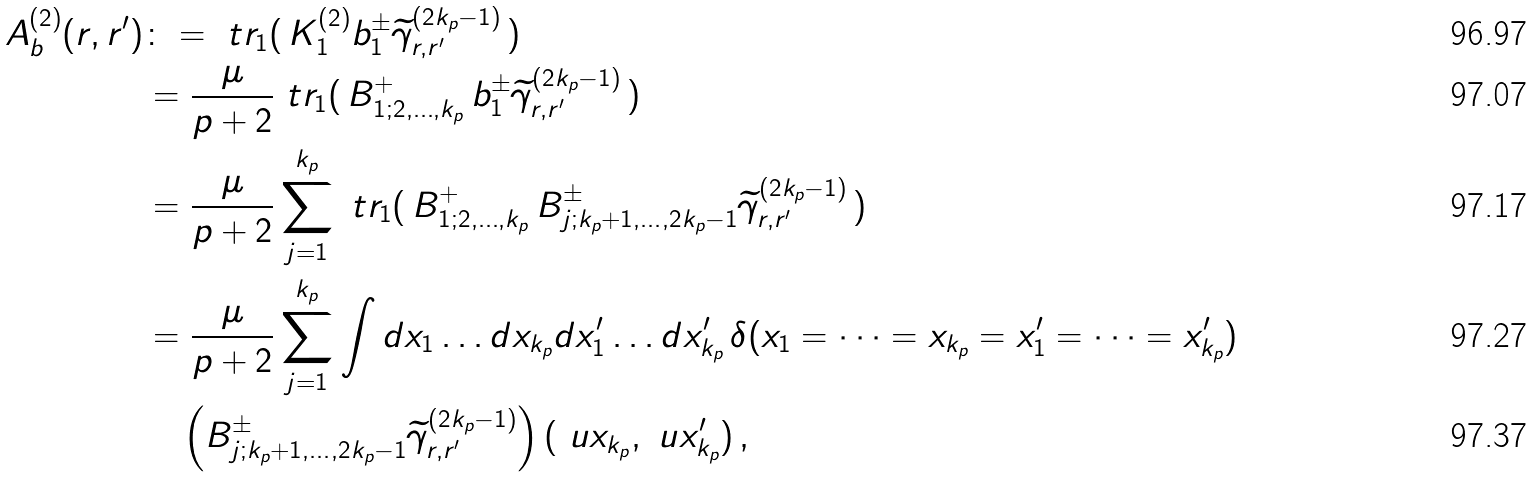<formula> <loc_0><loc_0><loc_500><loc_500>A _ { b } ^ { ( 2 ) } ( r , r ^ { \prime } ) & \colon = \ t r _ { 1 } ( \, K _ { 1 } ^ { ( 2 ) } b _ { 1 } ^ { \pm } \widetilde { \gamma } ^ { ( 2 k _ { p } - 1 ) } _ { r , r ^ { \prime } } \, ) \\ & = \frac { \mu } { p + 2 } \ t r _ { 1 } ( \, B ^ { + } _ { 1 ; 2 , \dots , k _ { p } } \, b _ { 1 } ^ { \pm } \widetilde { \gamma } ^ { ( 2 k _ { p } - 1 ) } _ { r , r ^ { \prime } } \, ) \\ & = \frac { \mu } { p + 2 } \sum _ { j = 1 } ^ { k _ { p } } \ t r _ { 1 } ( \, B ^ { + } _ { 1 ; 2 , \dots , k _ { p } } \, B ^ { \pm } _ { j ; k _ { p } + 1 , \dots , 2 k _ { p } - 1 } \widetilde { \gamma } ^ { ( 2 k _ { p } - 1 ) } _ { r , r ^ { \prime } } \, ) \\ & = \frac { \mu } { p + 2 } \sum _ { j = 1 } ^ { k _ { p } } \int d x _ { 1 } \dots d x _ { k _ { p } } d x ^ { \prime } _ { 1 } \dots d x ^ { \prime } _ { k _ { p } } \, \delta ( x _ { 1 } = \dots = x _ { k _ { p } } = x ^ { \prime } _ { 1 } = \dots = x ^ { \prime } _ { k _ { p } } ) \\ & \quad \left ( B ^ { \pm } _ { j ; k _ { p } + 1 , \dots , 2 k _ { p } - 1 } \widetilde { \gamma } ^ { ( 2 k _ { p } - 1 ) } _ { r , r ^ { \prime } } \right ) ( \ u x _ { k _ { p } } , \ u x ^ { \prime } _ { k _ { p } } ) \, ,</formula> 